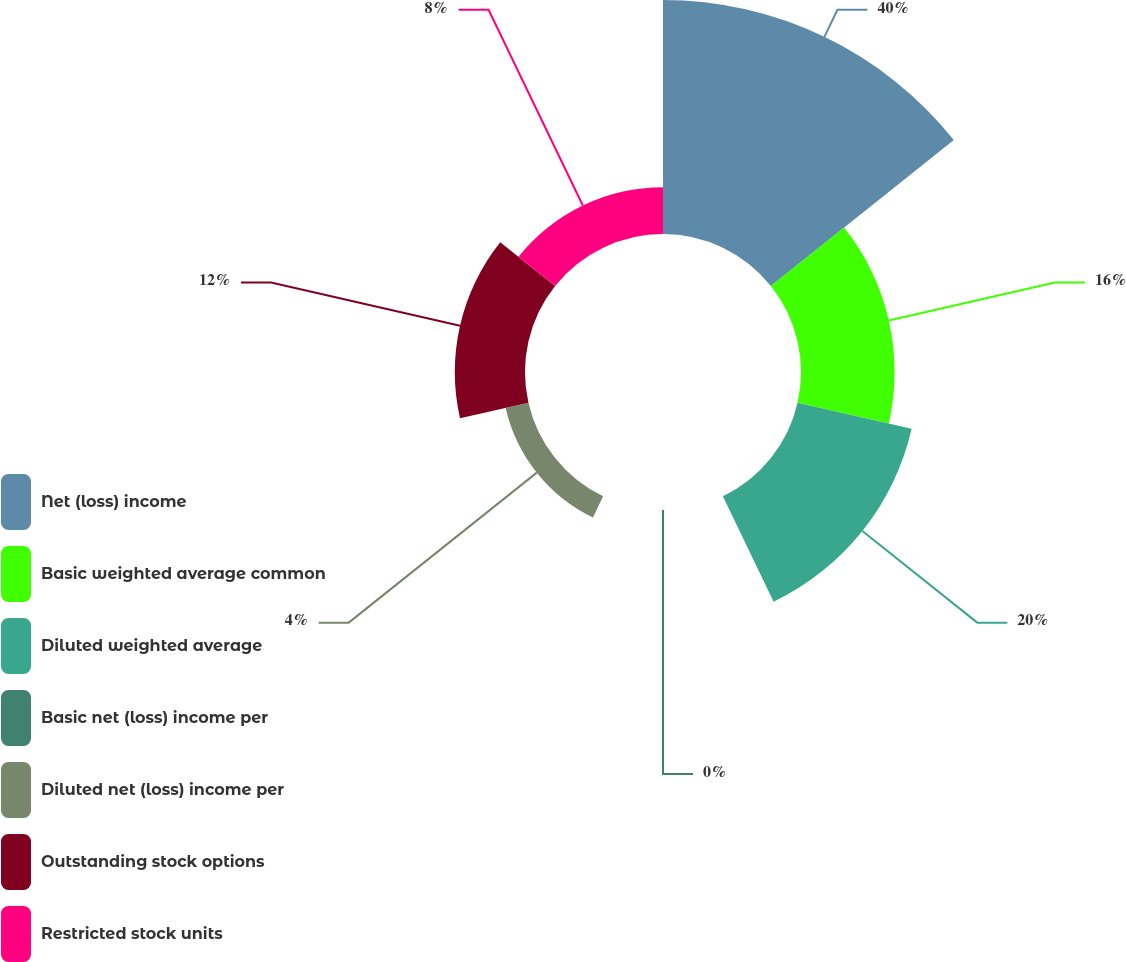Convert chart to OTSL. <chart><loc_0><loc_0><loc_500><loc_500><pie_chart><fcel>Net (loss) income<fcel>Basic weighted average common<fcel>Diluted weighted average<fcel>Basic net (loss) income per<fcel>Diluted net (loss) income per<fcel>Outstanding stock options<fcel>Restricted stock units<nl><fcel>40.0%<fcel>16.0%<fcel>20.0%<fcel>0.0%<fcel>4.0%<fcel>12.0%<fcel>8.0%<nl></chart> 